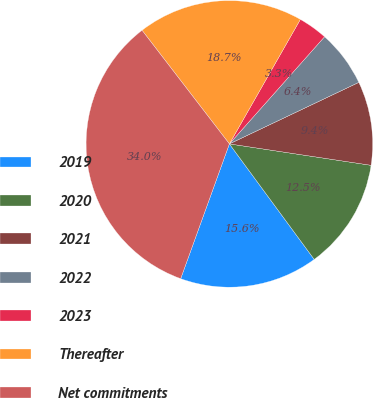Convert chart to OTSL. <chart><loc_0><loc_0><loc_500><loc_500><pie_chart><fcel>2019<fcel>2020<fcel>2021<fcel>2022<fcel>2023<fcel>Thereafter<fcel>Net commitments<nl><fcel>15.6%<fcel>12.53%<fcel>9.45%<fcel>6.38%<fcel>3.31%<fcel>18.68%<fcel>34.05%<nl></chart> 